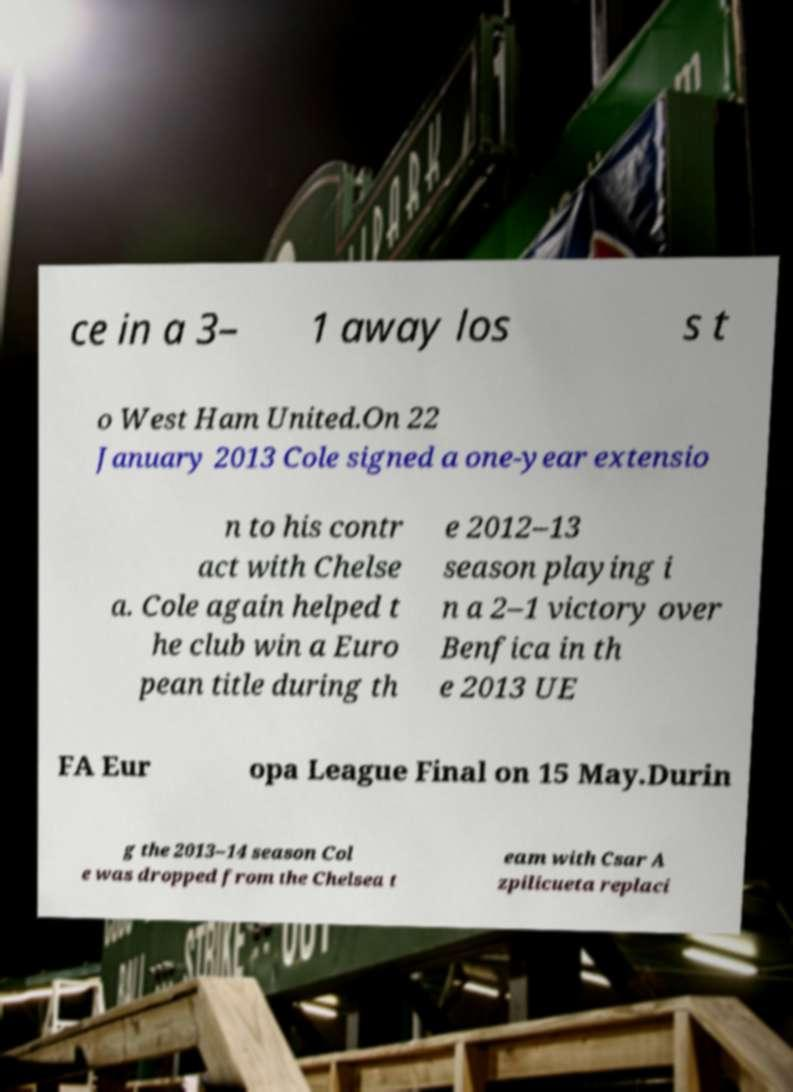Could you assist in decoding the text presented in this image and type it out clearly? ce in a 3– 1 away los s t o West Ham United.On 22 January 2013 Cole signed a one-year extensio n to his contr act with Chelse a. Cole again helped t he club win a Euro pean title during th e 2012–13 season playing i n a 2–1 victory over Benfica in th e 2013 UE FA Eur opa League Final on 15 May.Durin g the 2013–14 season Col e was dropped from the Chelsea t eam with Csar A zpilicueta replaci 